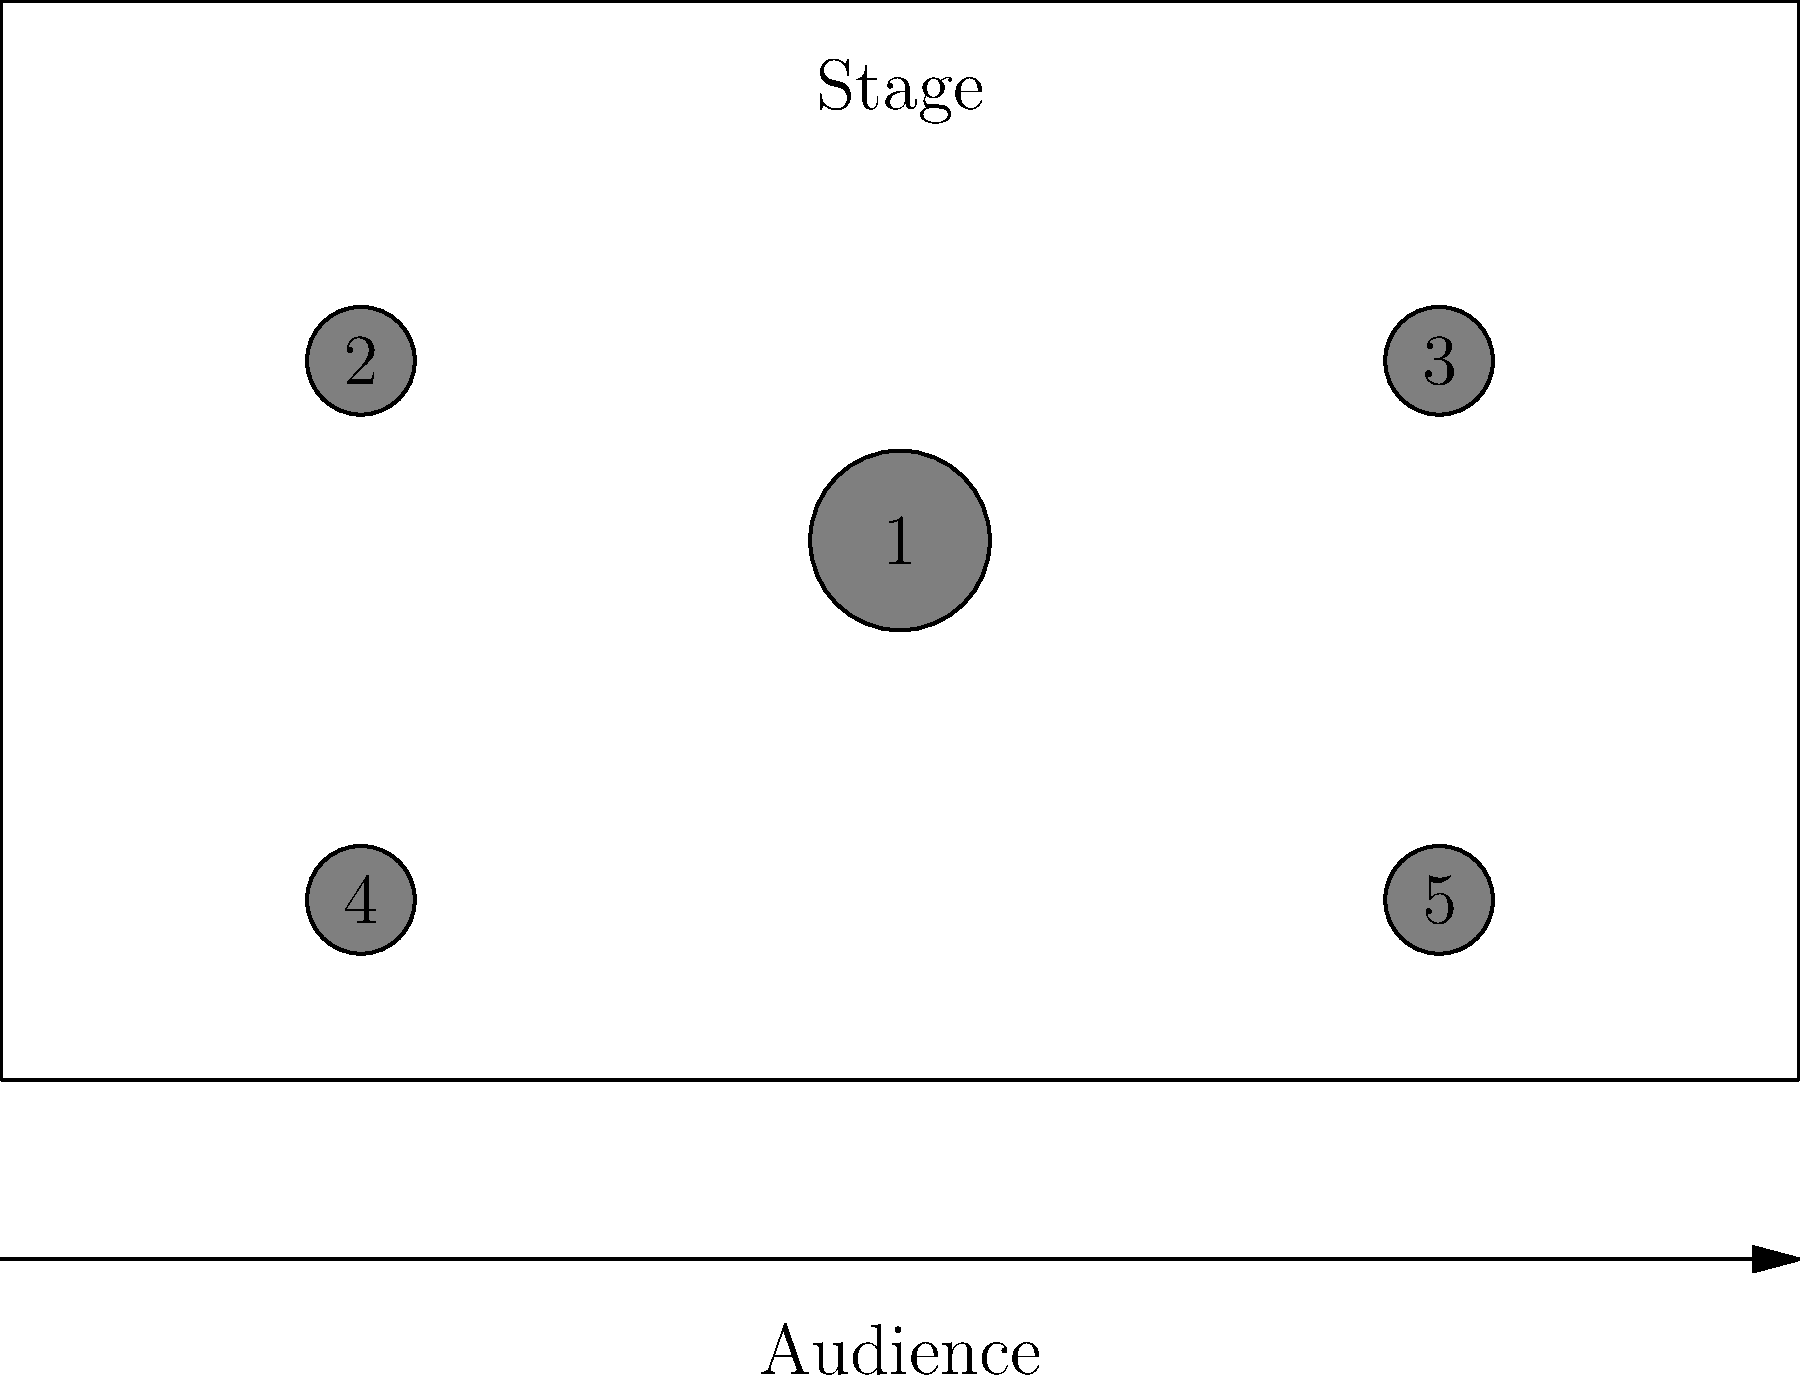In this stage setup diagram for an Alexandra Petkovski pop concert, which numbered position is most likely to represent the main synthesizer setup? To answer this question, let's analyze the stage setup diagram:

1. Position 1 is at the center of the stage. This is typically where the main artist or lead vocalist performs.

2. Positions 2 and 3 are symmetrically placed towards the back of the stage. These are often used for backup singers or additional instrumentalists.

3. Positions 4 and 5 are at the front corners of the stage. These are usually reserved for guitarists or other featured instrumentalists who need to move around during the performance.

Given that Alexandra Petkovski is known for her electronic and synth-pop music:

- The main synthesizer setup would need to be centrally located for easy access and visibility.
- It would likely be positioned behind the main vocal area to allow the artist to switch between singing and playing.

Therefore, position 1 is the most logical choice for the main synthesizer setup. It provides central positioning and allows Alexandra to easily transition between vocals and synthesizer playing during her performance.
Answer: Position 1 